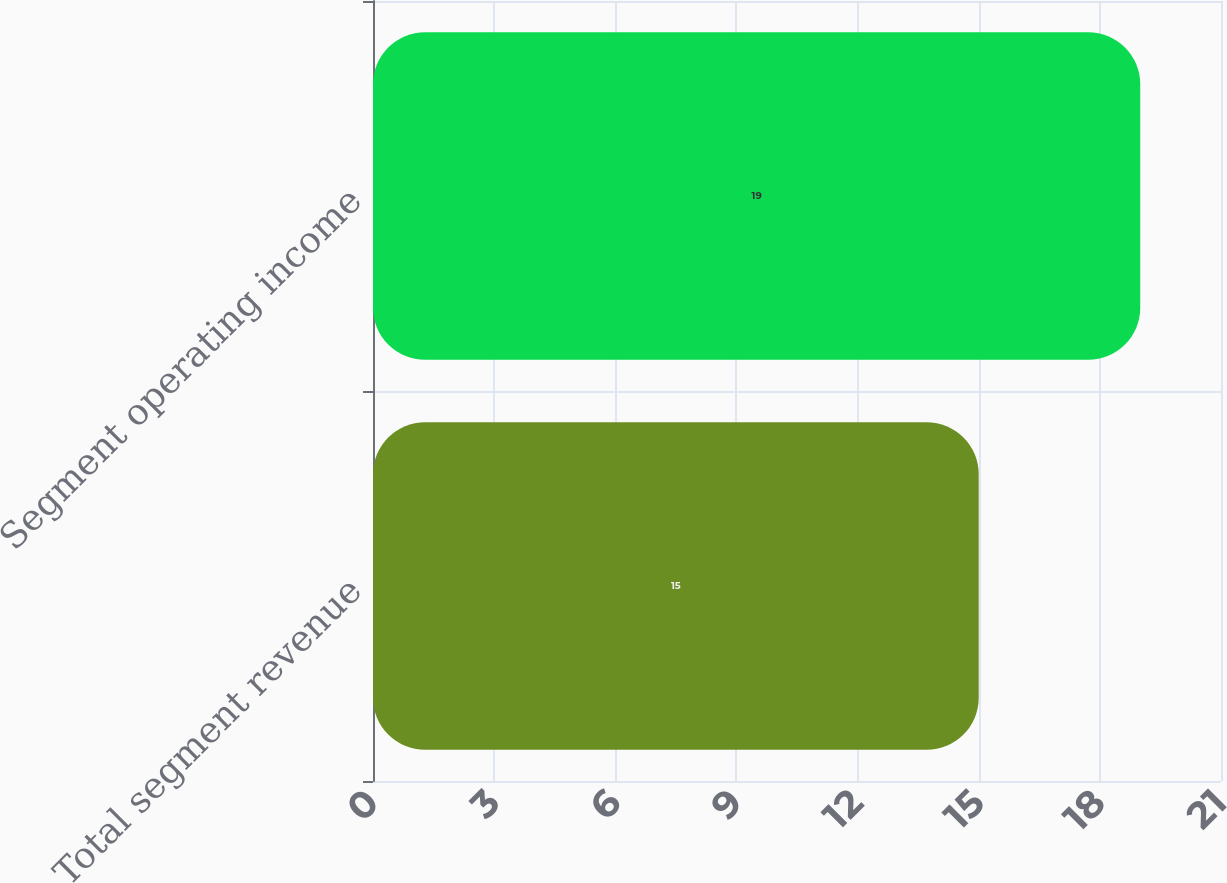Convert chart to OTSL. <chart><loc_0><loc_0><loc_500><loc_500><bar_chart><fcel>Total segment revenue<fcel>Segment operating income<nl><fcel>15<fcel>19<nl></chart> 